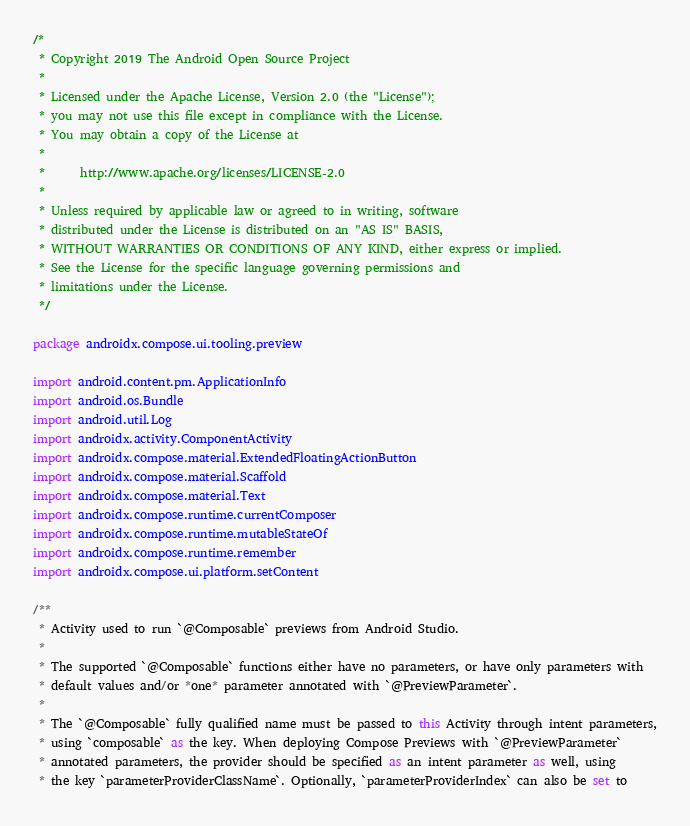Convert code to text. <code><loc_0><loc_0><loc_500><loc_500><_Kotlin_>/*
 * Copyright 2019 The Android Open Source Project
 *
 * Licensed under the Apache License, Version 2.0 (the "License");
 * you may not use this file except in compliance with the License.
 * You may obtain a copy of the License at
 *
 *      http://www.apache.org/licenses/LICENSE-2.0
 *
 * Unless required by applicable law or agreed to in writing, software
 * distributed under the License is distributed on an "AS IS" BASIS,
 * WITHOUT WARRANTIES OR CONDITIONS OF ANY KIND, either express or implied.
 * See the License for the specific language governing permissions and
 * limitations under the License.
 */

package androidx.compose.ui.tooling.preview

import android.content.pm.ApplicationInfo
import android.os.Bundle
import android.util.Log
import androidx.activity.ComponentActivity
import androidx.compose.material.ExtendedFloatingActionButton
import androidx.compose.material.Scaffold
import androidx.compose.material.Text
import androidx.compose.runtime.currentComposer
import androidx.compose.runtime.mutableStateOf
import androidx.compose.runtime.remember
import androidx.compose.ui.platform.setContent

/**
 * Activity used to run `@Composable` previews from Android Studio.
 *
 * The supported `@Composable` functions either have no parameters, or have only parameters with
 * default values and/or *one* parameter annotated with `@PreviewParameter`.
 *
 * The `@Composable` fully qualified name must be passed to this Activity through intent parameters,
 * using `composable` as the key. When deploying Compose Previews with `@PreviewParameter`
 * annotated parameters, the provider should be specified as an intent parameter as well, using
 * the key `parameterProviderClassName`. Optionally, `parameterProviderIndex` can also be set to</code> 